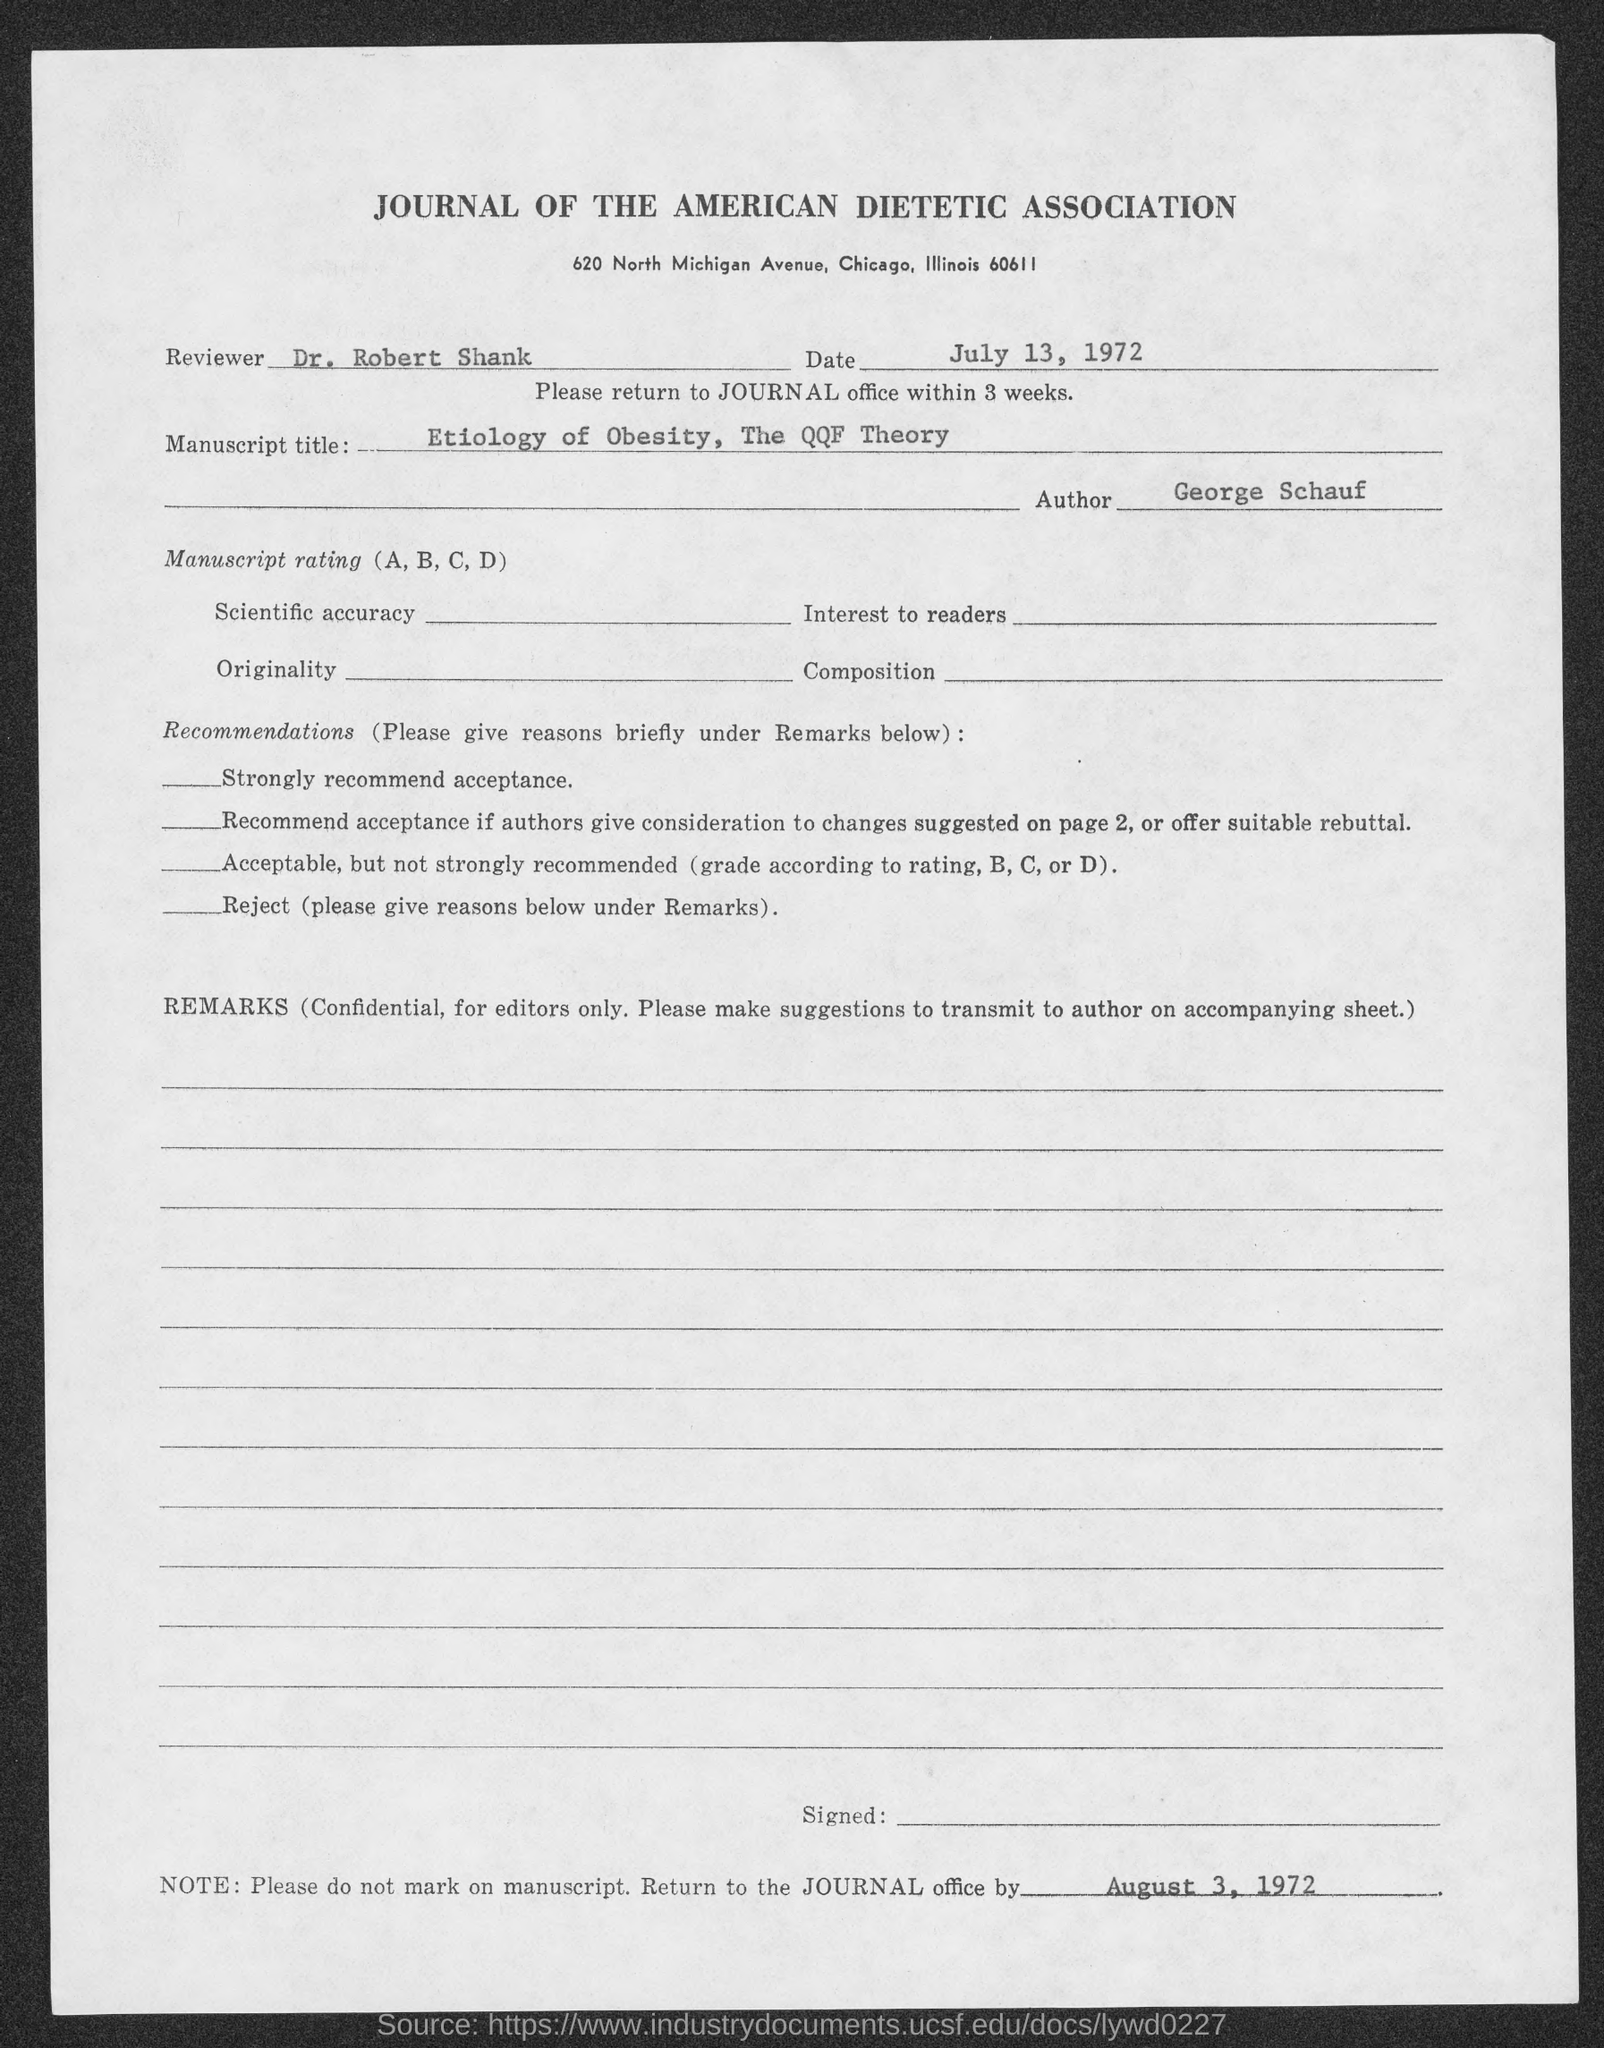Who is the Reviewer?
Ensure brevity in your answer.  Dr. Robert Shank. What is the Date?
Your response must be concise. July 13, 1972. Who is the Author?
Provide a short and direct response. George Schauf. Return to the journal office by what date?
Offer a terse response. August 3, 1972. 